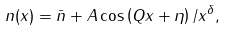<formula> <loc_0><loc_0><loc_500><loc_500>n ( x ) = \bar { n } + A \cos \left ( Q x + \eta \right ) / x ^ { \delta } ,</formula> 